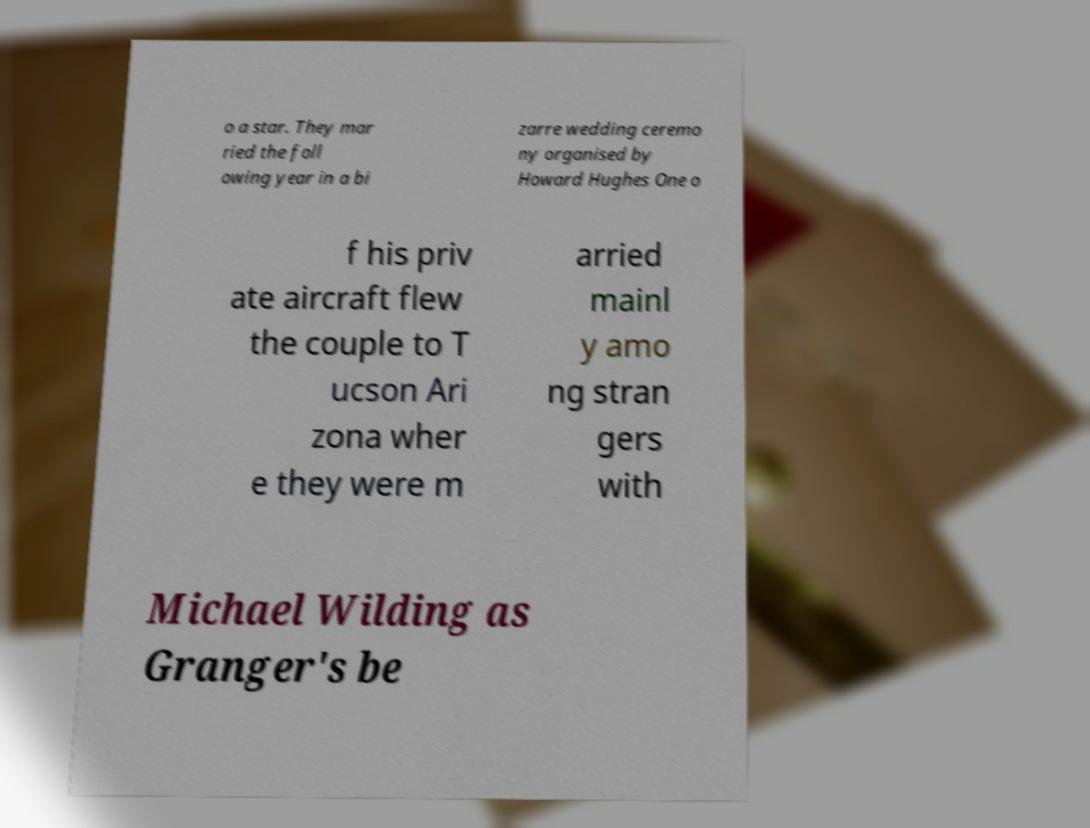Please identify and transcribe the text found in this image. o a star. They mar ried the foll owing year in a bi zarre wedding ceremo ny organised by Howard Hughes One o f his priv ate aircraft flew the couple to T ucson Ari zona wher e they were m arried mainl y amo ng stran gers with Michael Wilding as Granger's be 